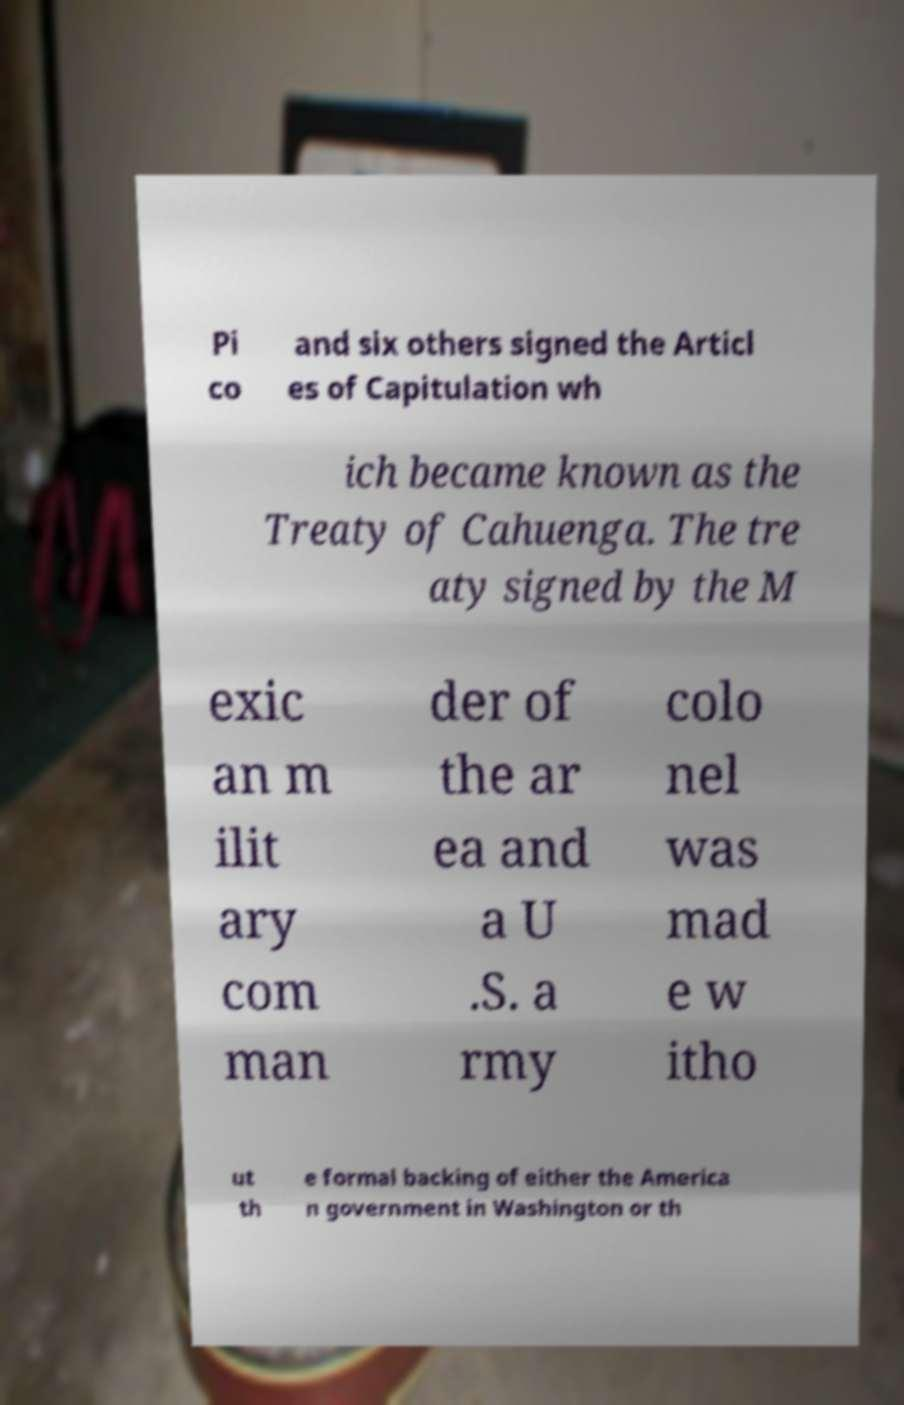Please identify and transcribe the text found in this image. Pi co and six others signed the Articl es of Capitulation wh ich became known as the Treaty of Cahuenga. The tre aty signed by the M exic an m ilit ary com man der of the ar ea and a U .S. a rmy colo nel was mad e w itho ut th e formal backing of either the America n government in Washington or th 